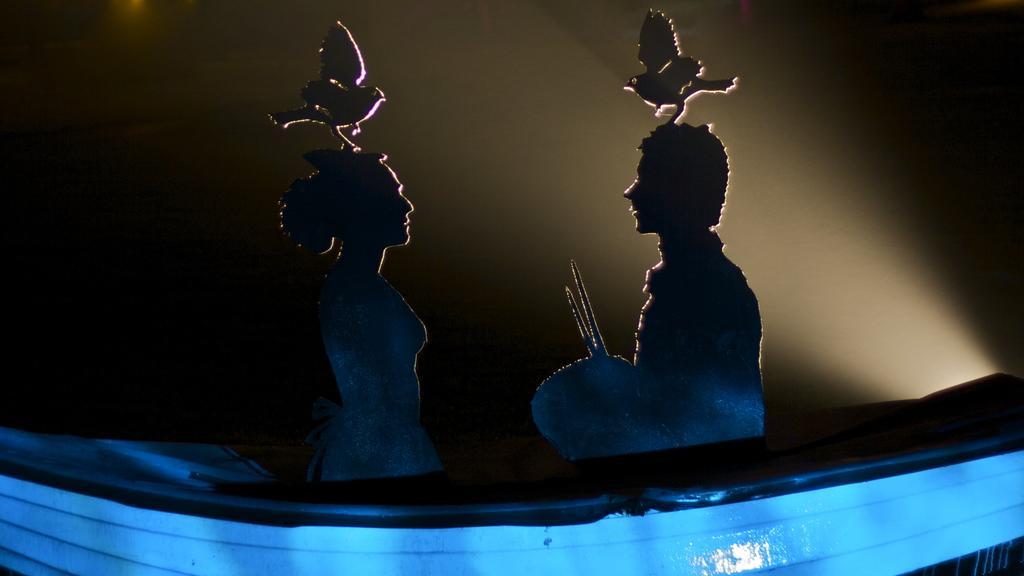Describe this image in one or two sentences. In the picture I can see some objects which are in the shape of people and birds. I can also see blue color object. The background of the image is dark. 